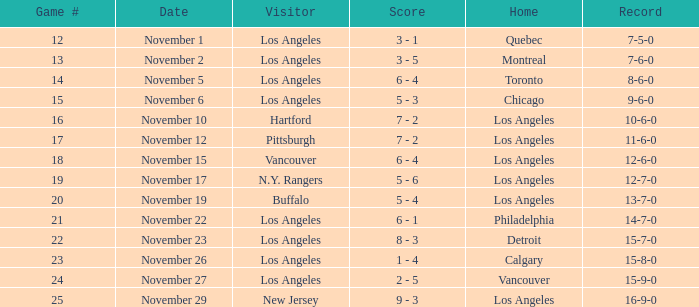What is the record of the game on November 22? 14-7-0. 